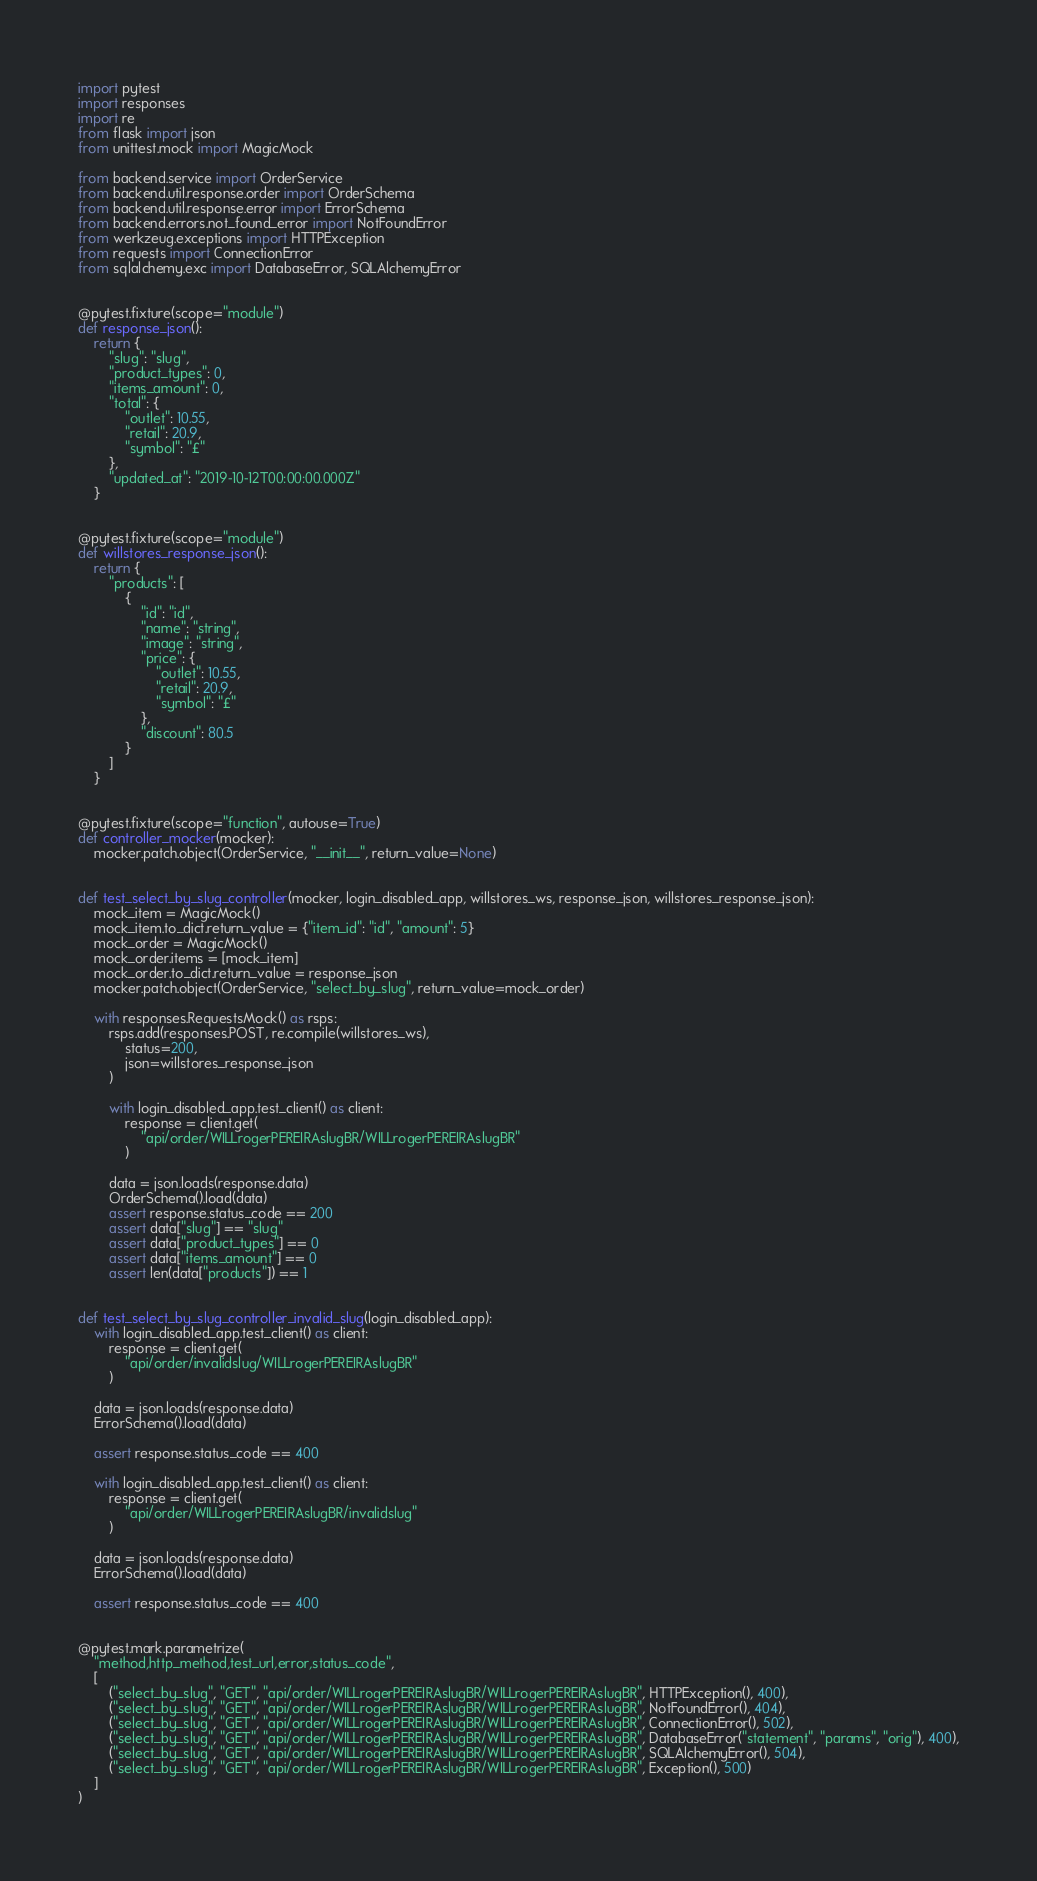Convert code to text. <code><loc_0><loc_0><loc_500><loc_500><_Python_>import pytest
import responses
import re
from flask import json
from unittest.mock import MagicMock

from backend.service import OrderService
from backend.util.response.order import OrderSchema
from backend.util.response.error import ErrorSchema
from backend.errors.not_found_error import NotFoundError
from werkzeug.exceptions import HTTPException
from requests import ConnectionError
from sqlalchemy.exc import DatabaseError, SQLAlchemyError


@pytest.fixture(scope="module")
def response_json():
    return {
        "slug": "slug",
        "product_types": 0,
        "items_amount": 0,
        "total": {
            "outlet": 10.55,
            "retail": 20.9,
            "symbol": "£"
        },
        "updated_at": "2019-10-12T00:00:00.000Z"
    }


@pytest.fixture(scope="module")
def willstores_response_json():
    return {
        "products": [
            {
                "id": "id",
                "name": "string",
                "image": "string",
                "price": {
                    "outlet": 10.55,
                    "retail": 20.9,
                    "symbol": "£"
                },
                "discount": 80.5
            }
        ]
    }


@pytest.fixture(scope="function", autouse=True)
def controller_mocker(mocker):
    mocker.patch.object(OrderService, "__init__", return_value=None)


def test_select_by_slug_controller(mocker, login_disabled_app, willstores_ws, response_json, willstores_response_json):
    mock_item = MagicMock()
    mock_item.to_dict.return_value = {"item_id": "id", "amount": 5}
    mock_order = MagicMock()
    mock_order.items = [mock_item]
    mock_order.to_dict.return_value = response_json
    mocker.patch.object(OrderService, "select_by_slug", return_value=mock_order)

    with responses.RequestsMock() as rsps:
        rsps.add(responses.POST, re.compile(willstores_ws),
            status=200,
            json=willstores_response_json
        )

        with login_disabled_app.test_client() as client:
            response = client.get(
                "api/order/WILLrogerPEREIRAslugBR/WILLrogerPEREIRAslugBR"
            )

        data = json.loads(response.data)
        OrderSchema().load(data)
        assert response.status_code == 200
        assert data["slug"] == "slug"
        assert data["product_types"] == 0
        assert data["items_amount"] == 0
        assert len(data["products"]) == 1


def test_select_by_slug_controller_invalid_slug(login_disabled_app):
    with login_disabled_app.test_client() as client:
        response = client.get(
            "api/order/invalidslug/WILLrogerPEREIRAslugBR"
        )

    data = json.loads(response.data)
    ErrorSchema().load(data)

    assert response.status_code == 400

    with login_disabled_app.test_client() as client:
        response = client.get(
            "api/order/WILLrogerPEREIRAslugBR/invalidslug"
        )

    data = json.loads(response.data)
    ErrorSchema().load(data)

    assert response.status_code == 400


@pytest.mark.parametrize(
    "method,http_method,test_url,error,status_code",
    [
        ("select_by_slug", "GET", "api/order/WILLrogerPEREIRAslugBR/WILLrogerPEREIRAslugBR", HTTPException(), 400),
        ("select_by_slug", "GET", "api/order/WILLrogerPEREIRAslugBR/WILLrogerPEREIRAslugBR", NotFoundError(), 404),
        ("select_by_slug", "GET", "api/order/WILLrogerPEREIRAslugBR/WILLrogerPEREIRAslugBR", ConnectionError(), 502),
        ("select_by_slug", "GET", "api/order/WILLrogerPEREIRAslugBR/WILLrogerPEREIRAslugBR", DatabaseError("statement", "params", "orig"), 400),
        ("select_by_slug", "GET", "api/order/WILLrogerPEREIRAslugBR/WILLrogerPEREIRAslugBR", SQLAlchemyError(), 504),
        ("select_by_slug", "GET", "api/order/WILLrogerPEREIRAslugBR/WILLrogerPEREIRAslugBR", Exception(), 500)
    ]
)</code> 